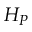<formula> <loc_0><loc_0><loc_500><loc_500>H _ { P }</formula> 